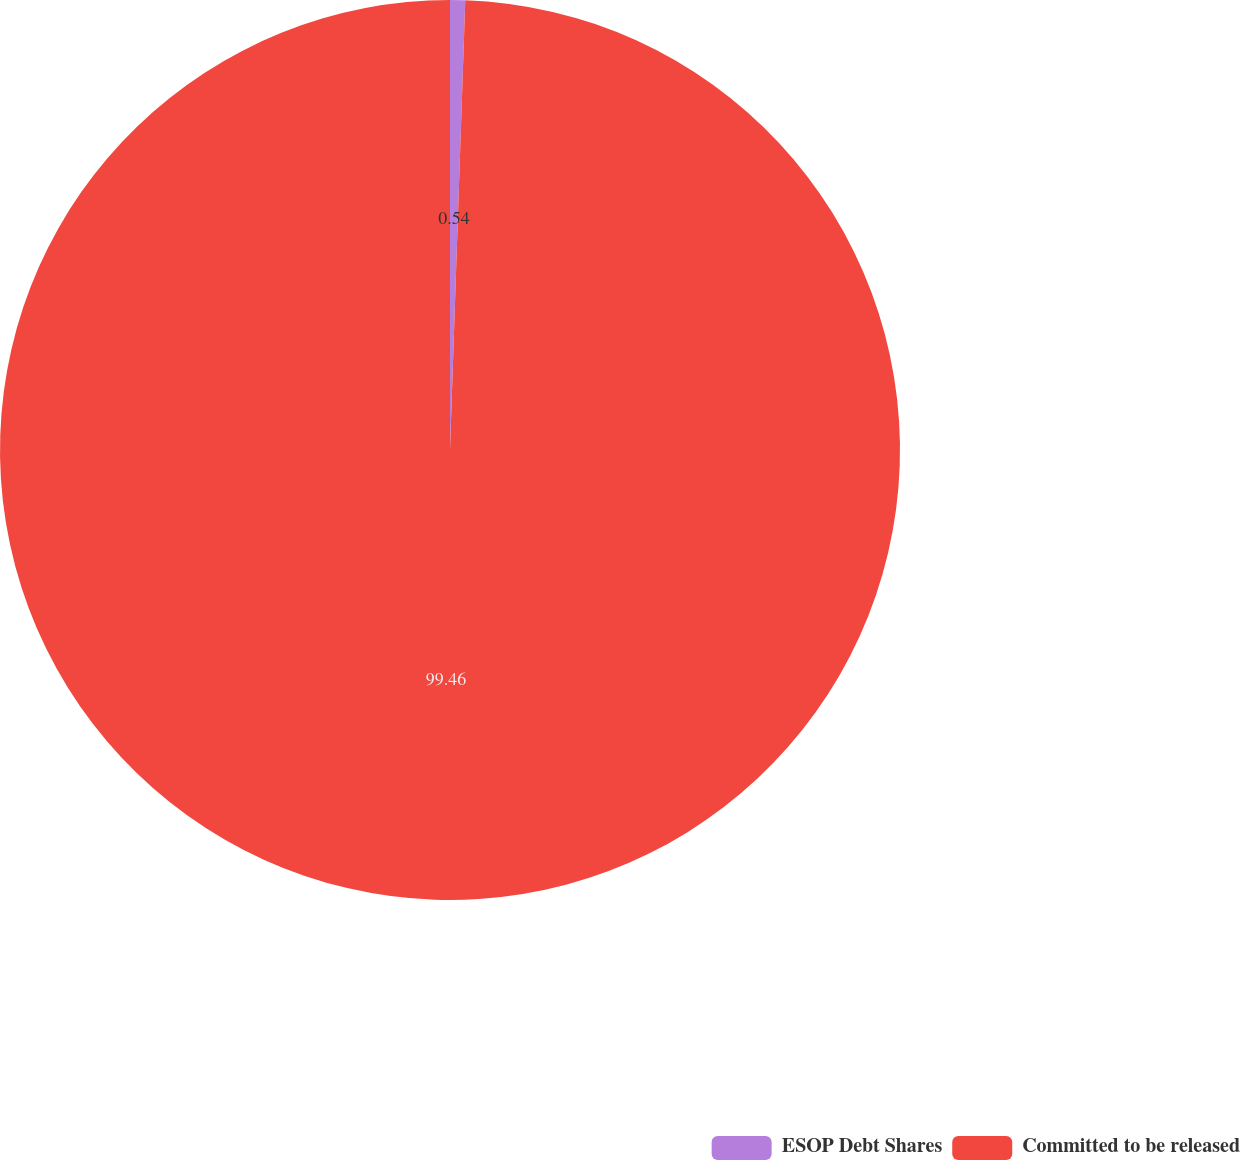<chart> <loc_0><loc_0><loc_500><loc_500><pie_chart><fcel>ESOP Debt Shares<fcel>Committed to be released<nl><fcel>0.54%<fcel>99.46%<nl></chart> 